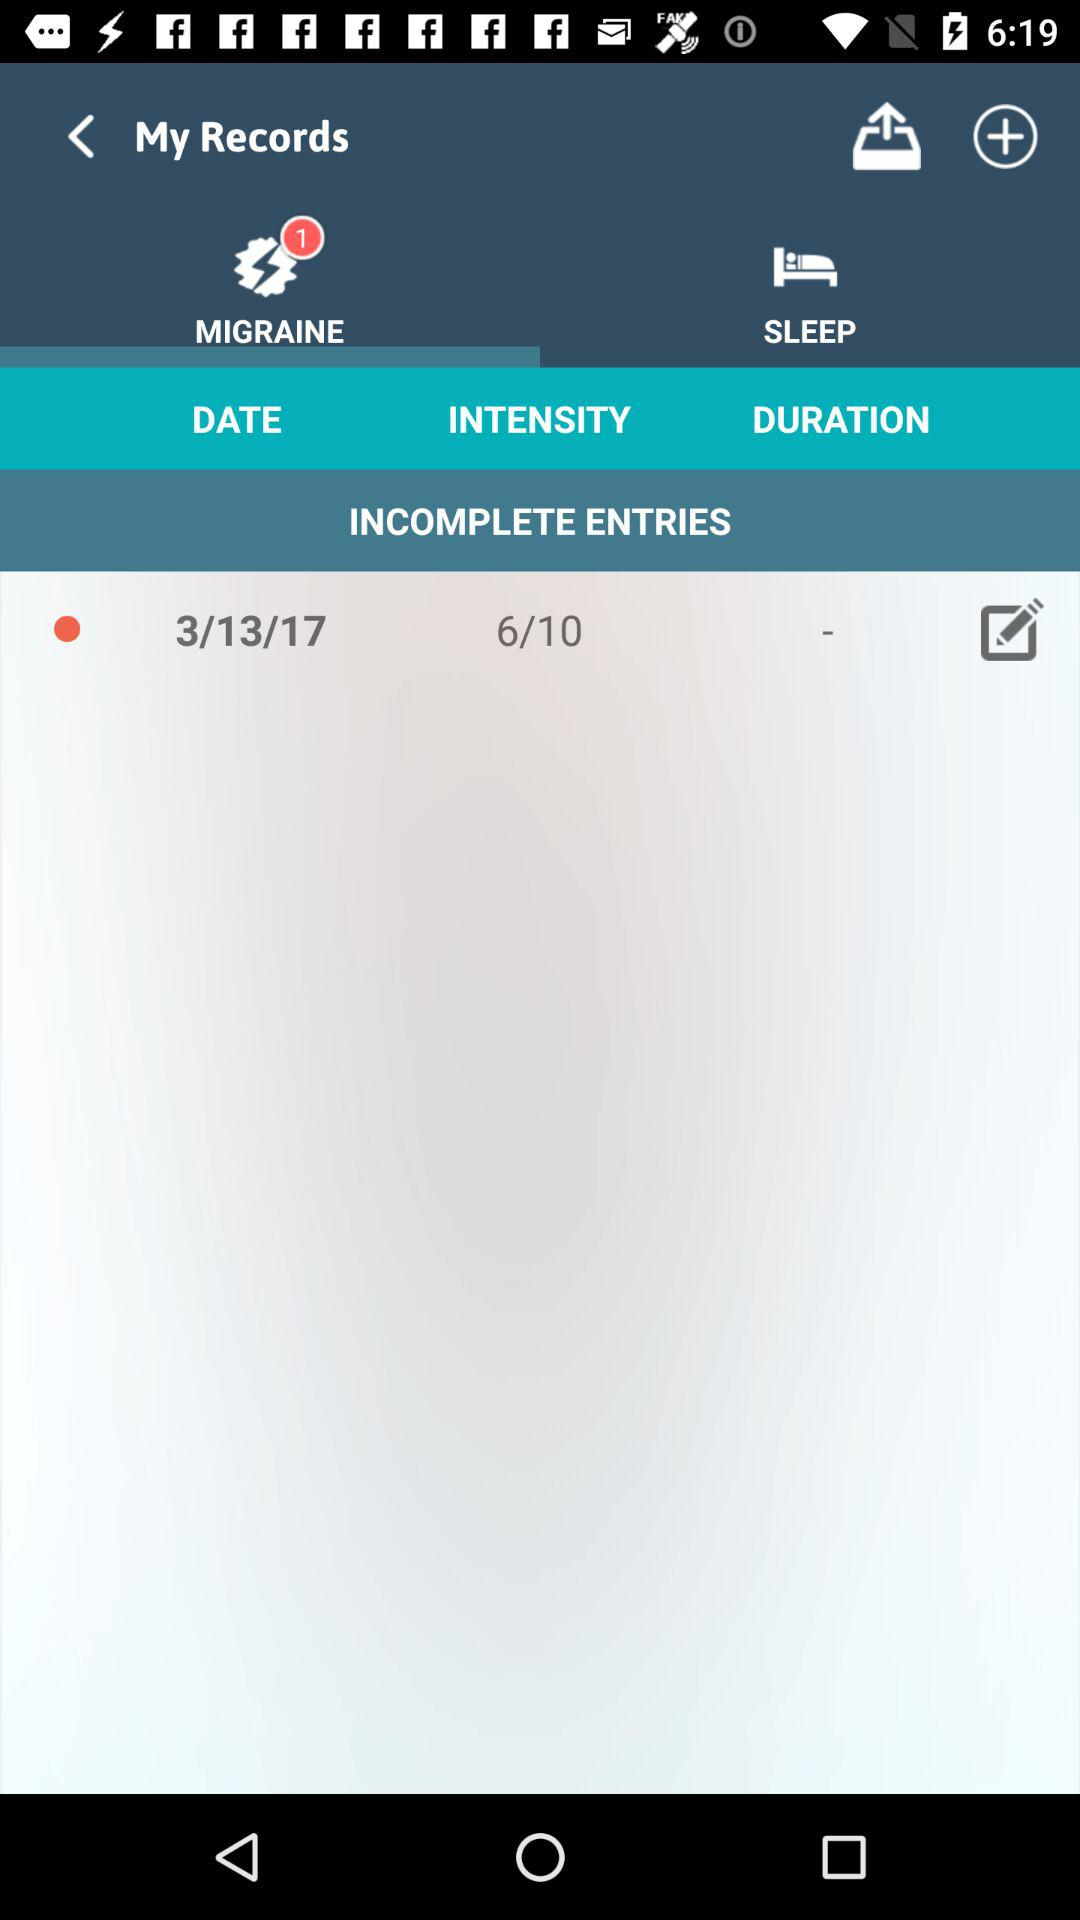Which tab is selected right now? The selected tab is "MIGRAINE". 